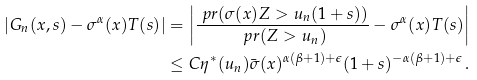<formula> <loc_0><loc_0><loc_500><loc_500>\left | G _ { n } ( x , s ) - \sigma ^ { \alpha } ( x ) T ( s ) \right | & = \left | \frac { \ p r ( \sigma ( x ) Z > u _ { n } ( 1 + s ) ) } { \ p r ( Z > u _ { n } ) } - \sigma ^ { \alpha } ( x ) T ( s ) \right | \\ & \leq C \eta ^ { * } ( u _ { n } ) \bar { \sigma } ( x ) ^ { \alpha ( \beta + 1 ) + \epsilon } ( 1 + s ) ^ { - \alpha ( \beta + 1 ) + \epsilon } \, .</formula> 